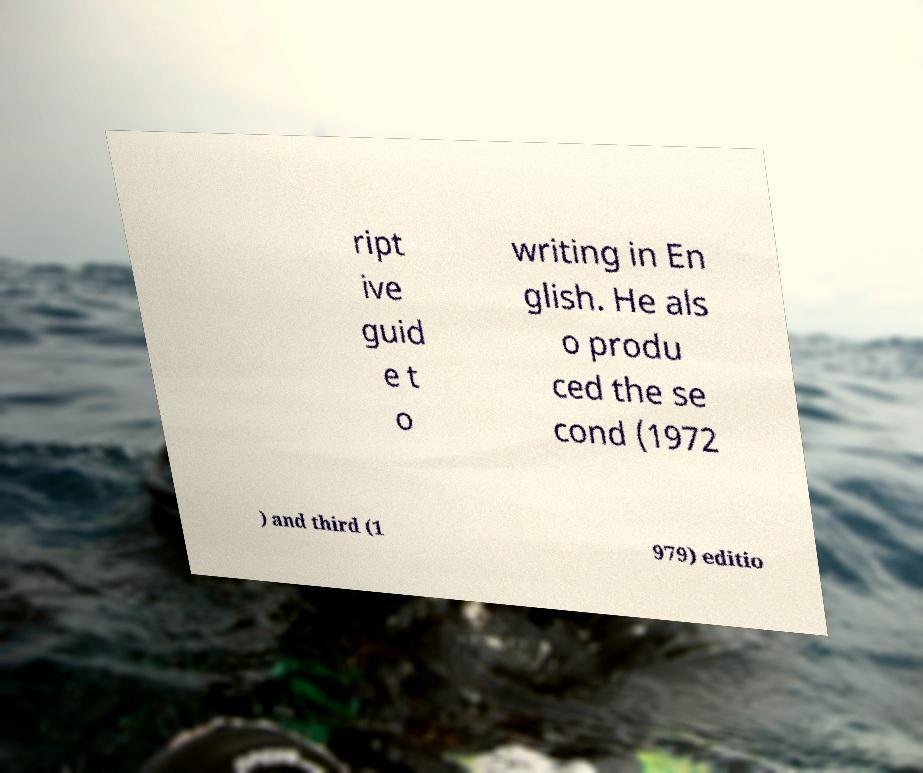Could you assist in decoding the text presented in this image and type it out clearly? ript ive guid e t o writing in En glish. He als o produ ced the se cond (1972 ) and third (1 979) editio 